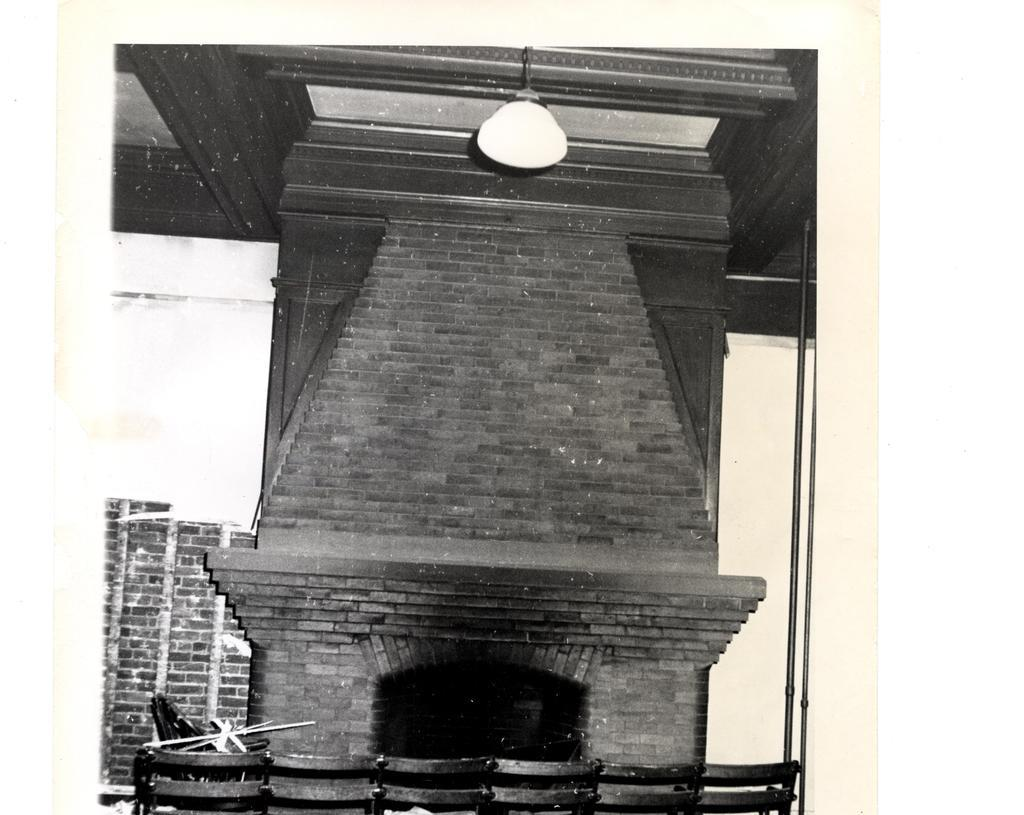What type of structure is visible in the image? There is a wall in the image. What type of furniture is present in the image? There are chairs in the image. Where is the light source located in the image? There is a light at the top of the image. What type of camp can be seen in the image? There is no camp present in the image; it features a wall, chairs, and a light. What nation is represented in the image? The image does not represent any specific nation; it is a general scene with a wall, chairs, and a light. 